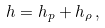<formula> <loc_0><loc_0><loc_500><loc_500>h = h _ { p } + h _ { \rho } \, ,</formula> 